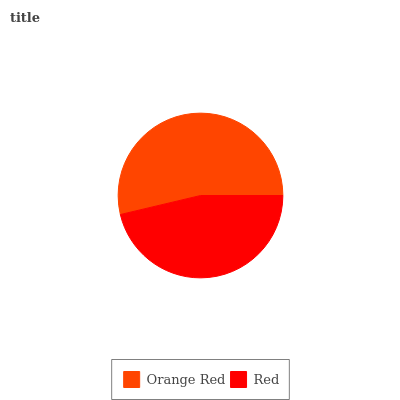Is Red the minimum?
Answer yes or no. Yes. Is Orange Red the maximum?
Answer yes or no. Yes. Is Red the maximum?
Answer yes or no. No. Is Orange Red greater than Red?
Answer yes or no. Yes. Is Red less than Orange Red?
Answer yes or no. Yes. Is Red greater than Orange Red?
Answer yes or no. No. Is Orange Red less than Red?
Answer yes or no. No. Is Orange Red the high median?
Answer yes or no. Yes. Is Red the low median?
Answer yes or no. Yes. Is Red the high median?
Answer yes or no. No. Is Orange Red the low median?
Answer yes or no. No. 